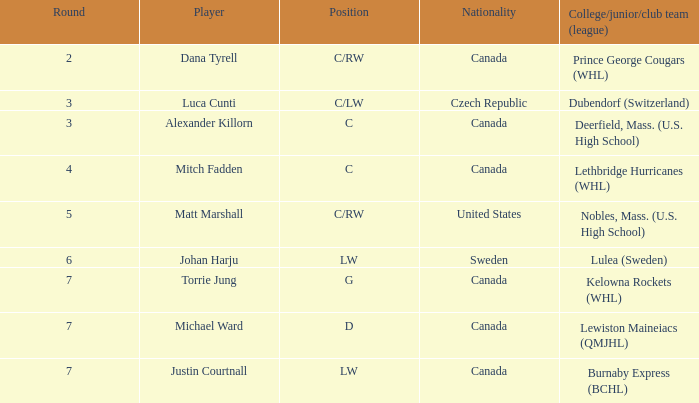Would you be able to parse every entry in this table? {'header': ['Round', 'Player', 'Position', 'Nationality', 'College/junior/club team (league)'], 'rows': [['2', 'Dana Tyrell', 'C/RW', 'Canada', 'Prince George Cougars (WHL)'], ['3', 'Luca Cunti', 'C/LW', 'Czech Republic', 'Dubendorf (Switzerland)'], ['3', 'Alexander Killorn', 'C', 'Canada', 'Deerfield, Mass. (U.S. High School)'], ['4', 'Mitch Fadden', 'C', 'Canada', 'Lethbridge Hurricanes (WHL)'], ['5', 'Matt Marshall', 'C/RW', 'United States', 'Nobles, Mass. (U.S. High School)'], ['6', 'Johan Harju', 'LW', 'Sweden', 'Lulea (Sweden)'], ['7', 'Torrie Jung', 'G', 'Canada', 'Kelowna Rockets (WHL)'], ['7', 'Michael Ward', 'D', 'Canada', 'Lewiston Maineiacs (QMJHL)'], ['7', 'Justin Courtnall', 'LW', 'Canada', 'Burnaby Express (BCHL)']]} What College/junior/club team (league) did mitch fadden play for? Lethbridge Hurricanes (WHL). 